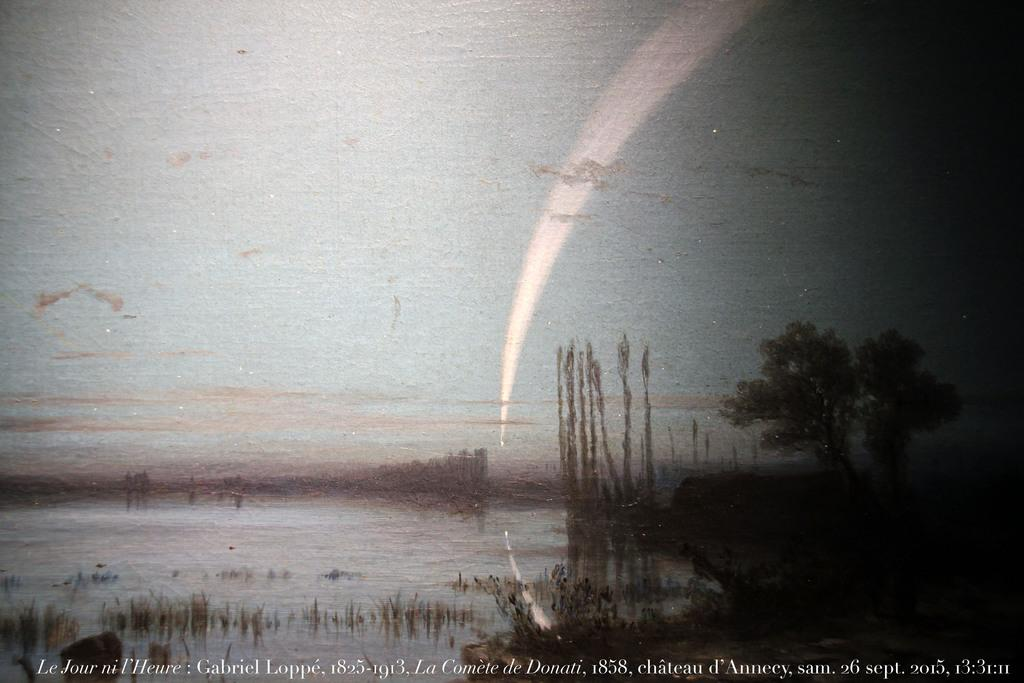What type of artwork is the image? The image is a painting. What natural elements can be seen in the painting? There are trees, water, grass, and plants visible in the image. Are there any human figures in the painting? Yes, there are persons in the image. What part of the natural environment is visible in the painting? The sky is visible in the image. Is there any text present in the painting? Yes, there is text at the bottom of the image. What type of brick is used to construct the route in the image? There is no route or brick present in the image; it is a painting featuring natural elements and human figures. 